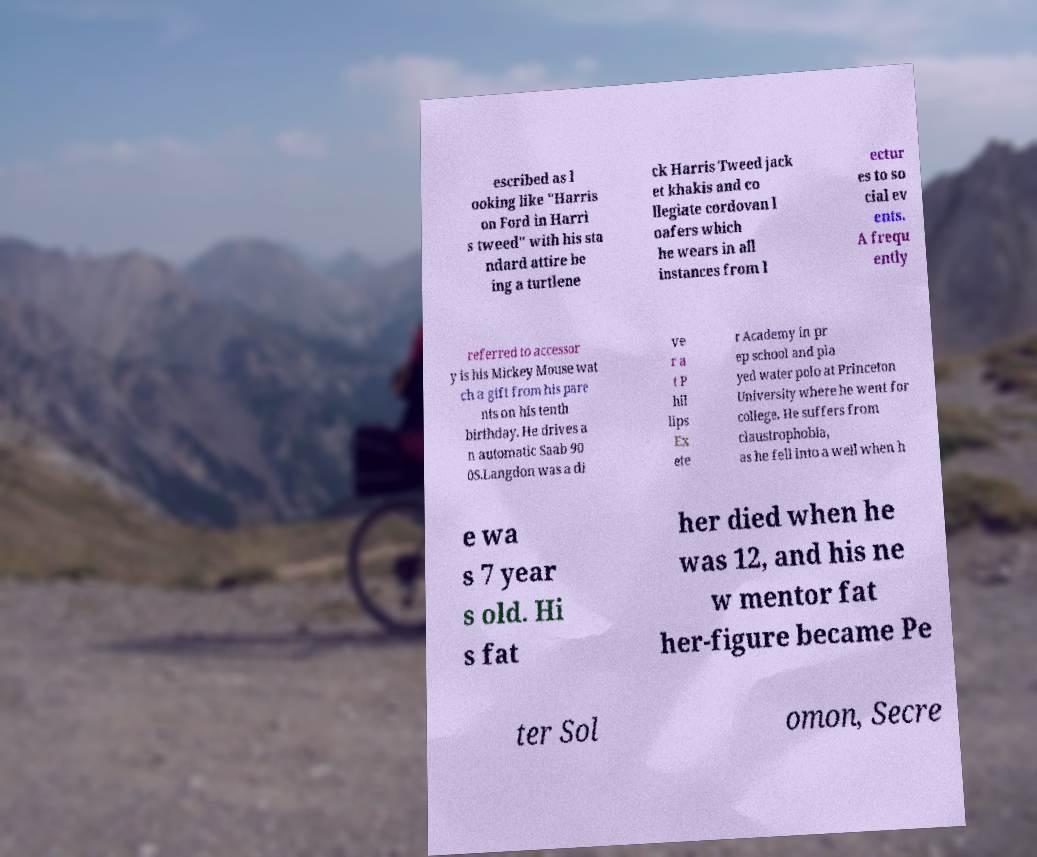Could you assist in decoding the text presented in this image and type it out clearly? escribed as l ooking like "Harris on Ford in Harri s tweed" with his sta ndard attire be ing a turtlene ck Harris Tweed jack et khakis and co llegiate cordovan l oafers which he wears in all instances from l ectur es to so cial ev ents. A frequ ently referred to accessor y is his Mickey Mouse wat ch a gift from his pare nts on his tenth birthday. He drives a n automatic Saab 90 0S.Langdon was a di ve r a t P hil lips Ex ete r Academy in pr ep school and pla yed water polo at Princeton University where he went for college. He suffers from claustrophobia, as he fell into a well when h e wa s 7 year s old. Hi s fat her died when he was 12, and his ne w mentor fat her-figure became Pe ter Sol omon, Secre 